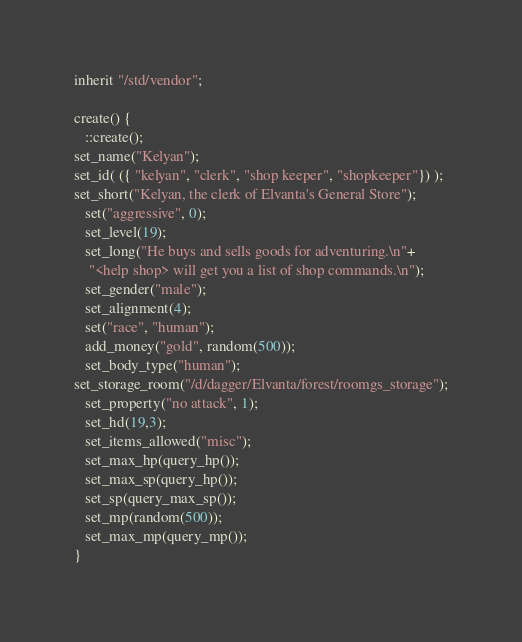<code> <loc_0><loc_0><loc_500><loc_500><_C_>inherit "/std/vendor";

create() {
   ::create();
set_name("Kelyan");
set_id( ({ "kelyan", "clerk", "shop keeper", "shopkeeper"}) );
set_short("Kelyan, the clerk of Elvanta's General Store");
   set("aggressive", 0);
   set_level(19);
   set_long("He buys and sells goods for adventuring.\n"+
	"<help shop> will get you a list of shop commands.\n");
   set_gender("male");
   set_alignment(4);
   set("race", "human");
   add_money("gold", random(500));
   set_body_type("human");
set_storage_room("/d/dagger/Elvanta/forest/roomgs_storage");
   set_property("no attack", 1);
   set_hd(19,3);
   set_items_allowed("misc");
   set_max_hp(query_hp());
   set_max_sp(query_hp());
   set_sp(query_max_sp());
   set_mp(random(500));
   set_max_mp(query_mp());
}
</code> 